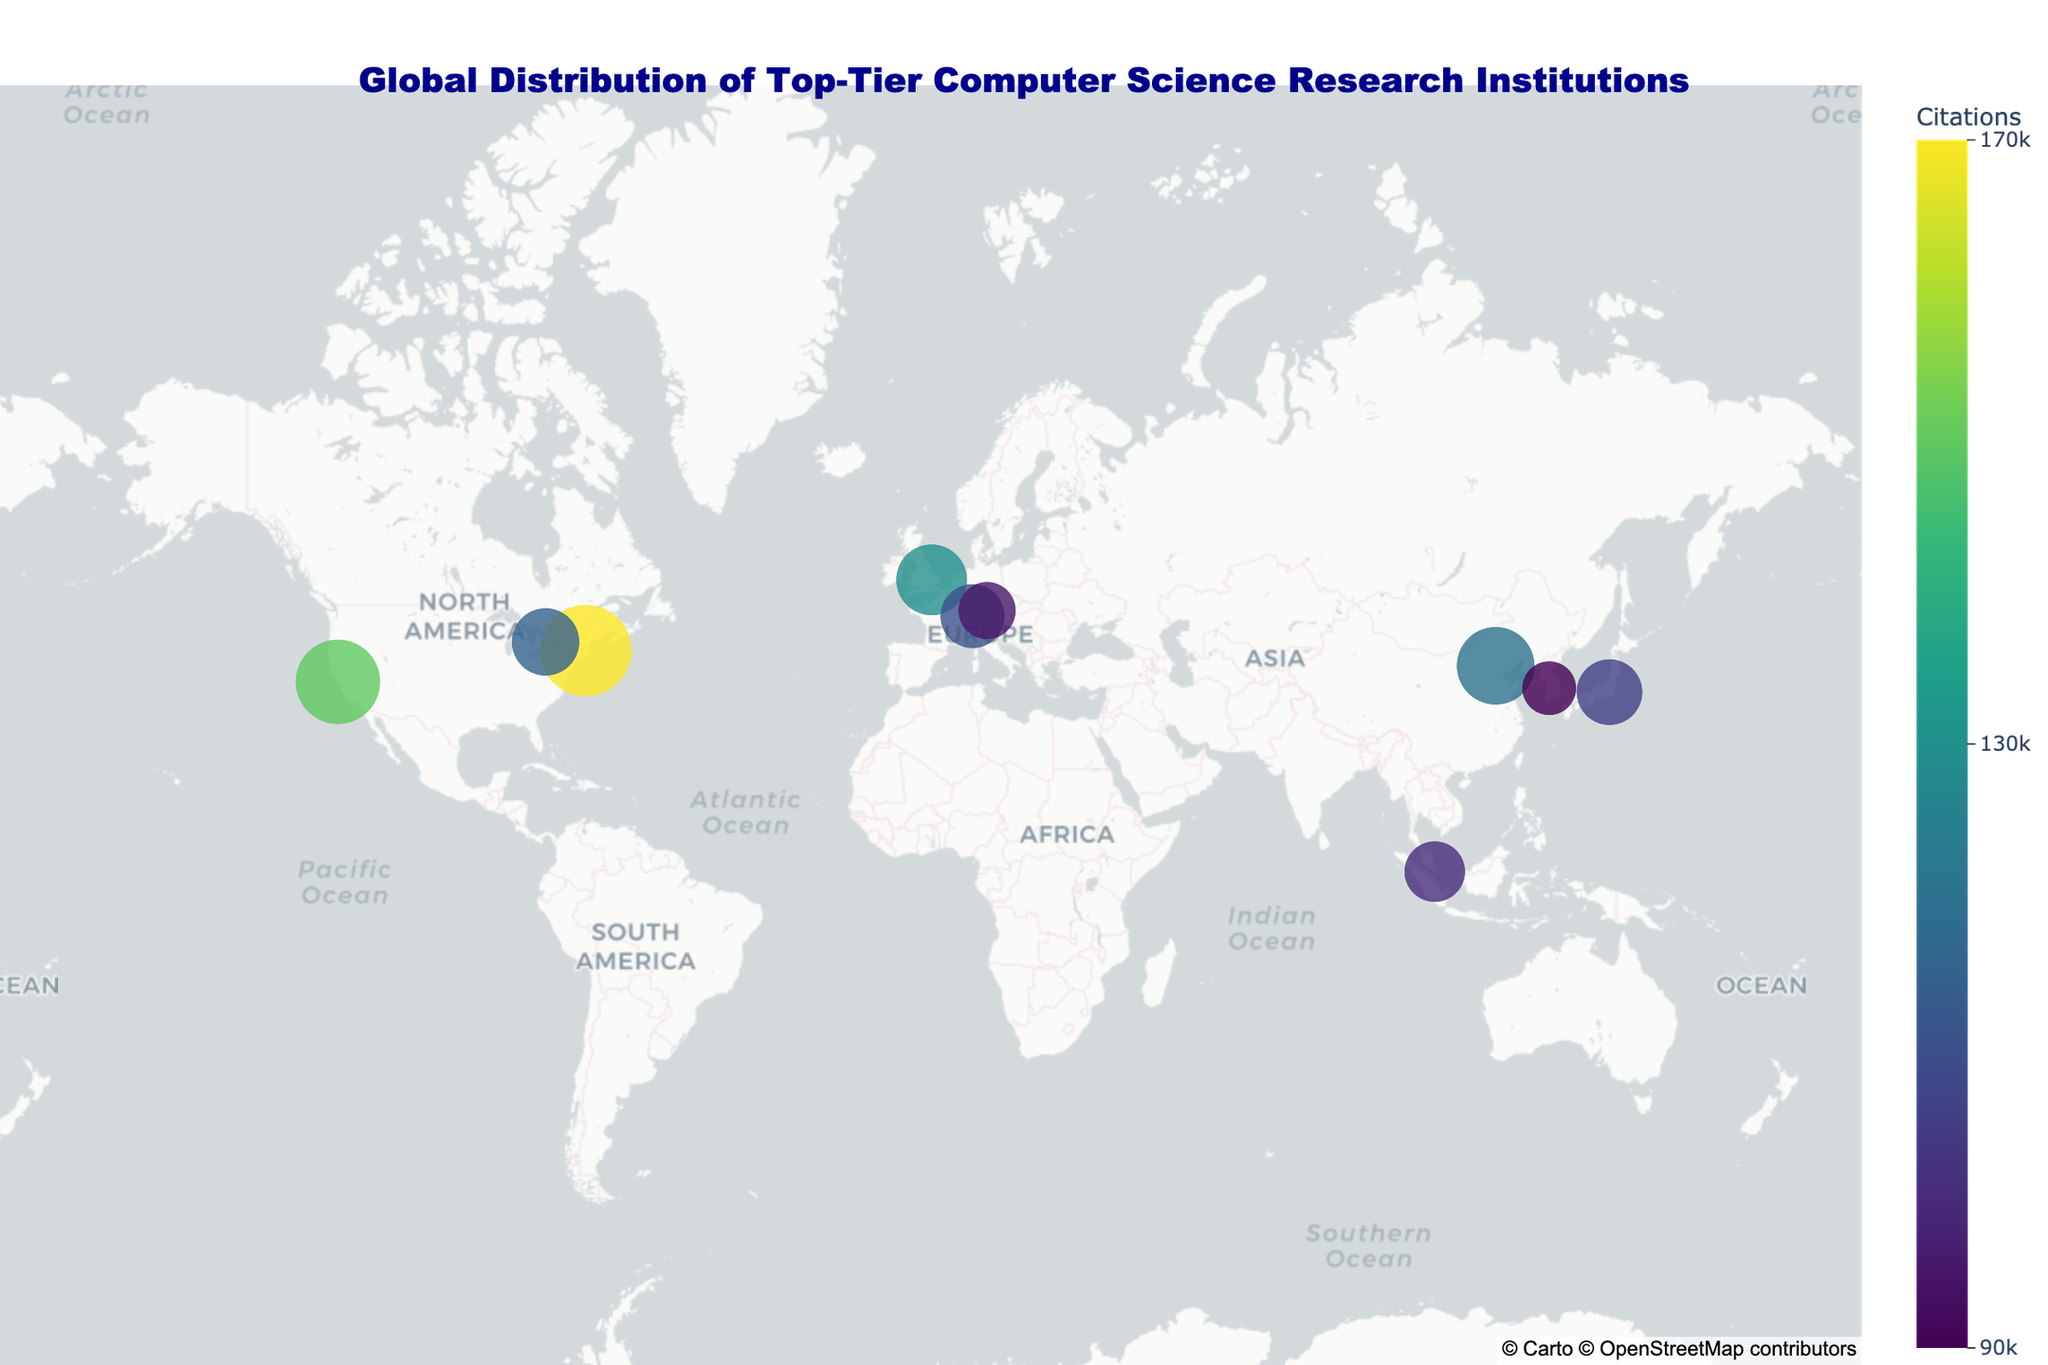What is the title of the plot? The title of the plot is usually found at the top center of the figure. In this case, it reads "Global Distribution of Top-Tier Computer Science Research Institutions".
Answer: Global Distribution of Top-Tier Computer Science Research Institutions Which institution is represented with the largest marker size? The size of the marker corresponds to the number of publications. The largest marker size indicates the institution with the most publications. In this plot, the largest marker is for the Massachusetts Institute of Technology (MIT) with 2700 publications.
Answer: Massachusetts Institute of Technology Which country has the second-highest number of citations attributed to its institution? By looking at the color scale indicating citations, find the institution with the second-highest citation count. Stanford University in the USA has 150,000 citations, and the University of Cambridge in the UK has the second-highest with 130,000 citations.
Answer: UK (University of Cambridge) How many institutions are located in Europe? Count the number of markers in Europe by identifying their locations. The institutions in Europe are the University of Cambridge (UK), ETH Zurich (Switzerland), and the Technical University of Munich (Germany), making a total of 3 institutions.
Answer: 3 Which institution has more publications, Tsinghua University or the University of Tokyo? Compare the number of publications listed for both institutions. Tsinghua University has 2300 publications, while the University of Tokyo has 1950 publications.
Answer: Tsinghua University How do the total number of citations between Stanford University and the National University of Singapore compare? Sum up the number of citations for each institution and then compare them. Stanford University has 150,000 citations, while the National University of Singapore has 100,000 citations.
Answer: Stanford University has more citations What is the average number of publications among all the listed institutions? Sum up the number of publications for all institutions and divide by the total number of institutions (10). The total publications are 2500 + 2100 + 1900 + 2300 + 2700 + 1800 + 2000 + 1700 + 1950 + 1600 = 20,550. The average is 20,550 / 10 = 2055.
Answer: 2055 Which institution is located furthest north? Consider the latitude values for the institutions. The higher the latitude, the further north the location. The University of Cambridge (UK) at 52.2053 has the highest latitude.
Answer: University of Cambridge Which two institutions have the closest number of citations, and what is the difference between them? Compare the number of citations across institutions to find the closest pair. ETH Zurich has 110,000 citations, and the University of Toronto has 115,000 citations, so the difference is 115,000 - 110,000 = 5,000.
Answer: ETH Zurich and University of Toronto, 5,000 